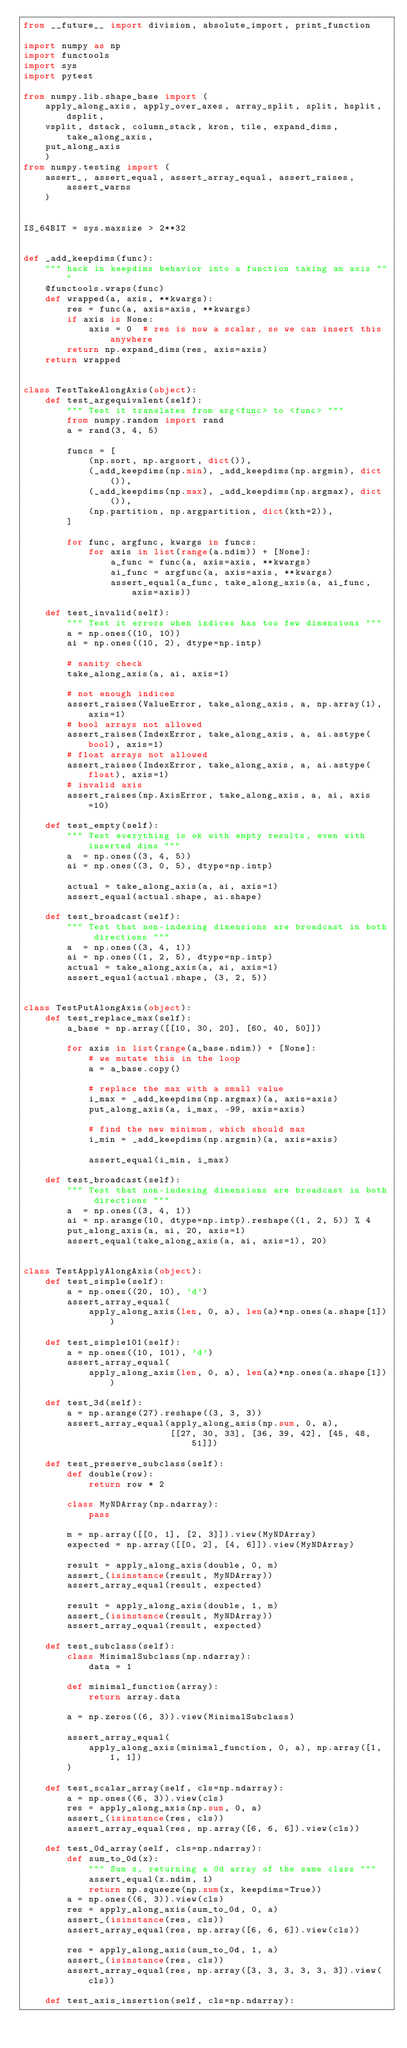Convert code to text. <code><loc_0><loc_0><loc_500><loc_500><_Python_>from __future__ import division, absolute_import, print_function

import numpy as np
import functools
import sys
import pytest

from numpy.lib.shape_base import (
    apply_along_axis, apply_over_axes, array_split, split, hsplit, dsplit,
    vsplit, dstack, column_stack, kron, tile, expand_dims, take_along_axis,
    put_along_axis
    )
from numpy.testing import (
    assert_, assert_equal, assert_array_equal, assert_raises, assert_warns
    )


IS_64BIT = sys.maxsize > 2**32


def _add_keepdims(func):
    """ hack in keepdims behavior into a function taking an axis """
    @functools.wraps(func)
    def wrapped(a, axis, **kwargs):
        res = func(a, axis=axis, **kwargs)
        if axis is None:
            axis = 0  # res is now a scalar, so we can insert this anywhere
        return np.expand_dims(res, axis=axis)
    return wrapped


class TestTakeAlongAxis(object):
    def test_argequivalent(self):
        """ Test it translates from arg<func> to <func> """
        from numpy.random import rand
        a = rand(3, 4, 5)

        funcs = [
            (np.sort, np.argsort, dict()),
            (_add_keepdims(np.min), _add_keepdims(np.argmin), dict()),
            (_add_keepdims(np.max), _add_keepdims(np.argmax), dict()),
            (np.partition, np.argpartition, dict(kth=2)),
        ]

        for func, argfunc, kwargs in funcs:
            for axis in list(range(a.ndim)) + [None]:
                a_func = func(a, axis=axis, **kwargs)
                ai_func = argfunc(a, axis=axis, **kwargs)
                assert_equal(a_func, take_along_axis(a, ai_func, axis=axis))

    def test_invalid(self):
        """ Test it errors when indices has too few dimensions """
        a = np.ones((10, 10))
        ai = np.ones((10, 2), dtype=np.intp)

        # sanity check
        take_along_axis(a, ai, axis=1)

        # not enough indices
        assert_raises(ValueError, take_along_axis, a, np.array(1), axis=1)
        # bool arrays not allowed
        assert_raises(IndexError, take_along_axis, a, ai.astype(bool), axis=1)
        # float arrays not allowed
        assert_raises(IndexError, take_along_axis, a, ai.astype(float), axis=1)
        # invalid axis
        assert_raises(np.AxisError, take_along_axis, a, ai, axis=10)

    def test_empty(self):
        """ Test everything is ok with empty results, even with inserted dims """
        a  = np.ones((3, 4, 5))
        ai = np.ones((3, 0, 5), dtype=np.intp)

        actual = take_along_axis(a, ai, axis=1)
        assert_equal(actual.shape, ai.shape)

    def test_broadcast(self):
        """ Test that non-indexing dimensions are broadcast in both directions """
        a  = np.ones((3, 4, 1))
        ai = np.ones((1, 2, 5), dtype=np.intp)
        actual = take_along_axis(a, ai, axis=1)
        assert_equal(actual.shape, (3, 2, 5))


class TestPutAlongAxis(object):
    def test_replace_max(self):
        a_base = np.array([[10, 30, 20], [60, 40, 50]])

        for axis in list(range(a_base.ndim)) + [None]:
            # we mutate this in the loop
            a = a_base.copy()

            # replace the max with a small value
            i_max = _add_keepdims(np.argmax)(a, axis=axis)
            put_along_axis(a, i_max, -99, axis=axis)

            # find the new minimum, which should max
            i_min = _add_keepdims(np.argmin)(a, axis=axis)

            assert_equal(i_min, i_max)

    def test_broadcast(self):
        """ Test that non-indexing dimensions are broadcast in both directions """
        a  = np.ones((3, 4, 1))
        ai = np.arange(10, dtype=np.intp).reshape((1, 2, 5)) % 4
        put_along_axis(a, ai, 20, axis=1)
        assert_equal(take_along_axis(a, ai, axis=1), 20)


class TestApplyAlongAxis(object):
    def test_simple(self):
        a = np.ones((20, 10), 'd')
        assert_array_equal(
            apply_along_axis(len, 0, a), len(a)*np.ones(a.shape[1]))

    def test_simple101(self):
        a = np.ones((10, 101), 'd')
        assert_array_equal(
            apply_along_axis(len, 0, a), len(a)*np.ones(a.shape[1]))

    def test_3d(self):
        a = np.arange(27).reshape((3, 3, 3))
        assert_array_equal(apply_along_axis(np.sum, 0, a),
                           [[27, 30, 33], [36, 39, 42], [45, 48, 51]])

    def test_preserve_subclass(self):
        def double(row):
            return row * 2

        class MyNDArray(np.ndarray):
            pass

        m = np.array([[0, 1], [2, 3]]).view(MyNDArray)
        expected = np.array([[0, 2], [4, 6]]).view(MyNDArray)

        result = apply_along_axis(double, 0, m)
        assert_(isinstance(result, MyNDArray))
        assert_array_equal(result, expected)

        result = apply_along_axis(double, 1, m)
        assert_(isinstance(result, MyNDArray))
        assert_array_equal(result, expected)

    def test_subclass(self):
        class MinimalSubclass(np.ndarray):
            data = 1

        def minimal_function(array):
            return array.data

        a = np.zeros((6, 3)).view(MinimalSubclass)

        assert_array_equal(
            apply_along_axis(minimal_function, 0, a), np.array([1, 1, 1])
        )

    def test_scalar_array(self, cls=np.ndarray):
        a = np.ones((6, 3)).view(cls)
        res = apply_along_axis(np.sum, 0, a)
        assert_(isinstance(res, cls))
        assert_array_equal(res, np.array([6, 6, 6]).view(cls))

    def test_0d_array(self, cls=np.ndarray):
        def sum_to_0d(x):
            """ Sum x, returning a 0d array of the same class """
            assert_equal(x.ndim, 1)
            return np.squeeze(np.sum(x, keepdims=True))
        a = np.ones((6, 3)).view(cls)
        res = apply_along_axis(sum_to_0d, 0, a)
        assert_(isinstance(res, cls))
        assert_array_equal(res, np.array([6, 6, 6]).view(cls))

        res = apply_along_axis(sum_to_0d, 1, a)
        assert_(isinstance(res, cls))
        assert_array_equal(res, np.array([3, 3, 3, 3, 3, 3]).view(cls))

    def test_axis_insertion(self, cls=np.ndarray):</code> 